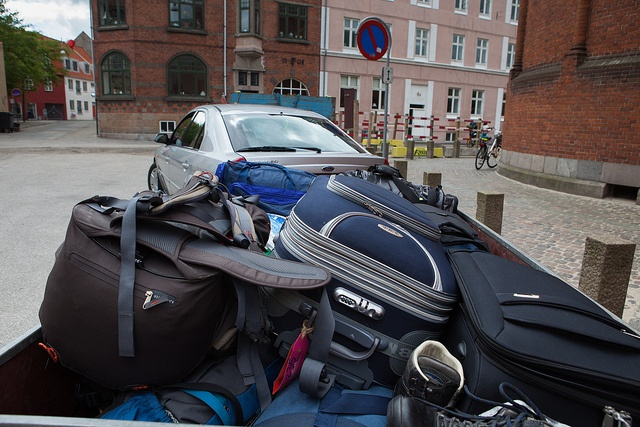Describe the objects in this image and their specific colors. I can see suitcase in darkgray, black, and gray tones, suitcase in darkgray, black, gray, navy, and darkblue tones, suitcase in darkgray, black, darkblue, and gray tones, car in darkgray, lightgray, gray, and lightblue tones, and suitcase in darkgray, black, navy, blue, and teal tones in this image. 